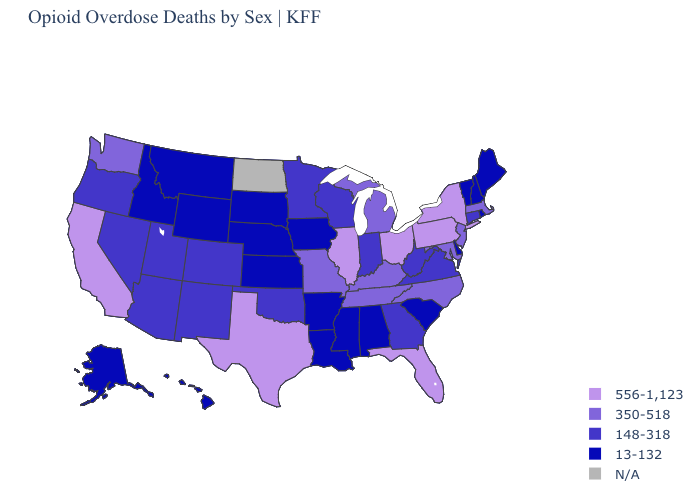Among the states that border Pennsylvania , which have the highest value?
Keep it brief. New York, Ohio. Name the states that have a value in the range 13-132?
Short answer required. Alabama, Alaska, Arkansas, Delaware, Hawaii, Idaho, Iowa, Kansas, Louisiana, Maine, Mississippi, Montana, Nebraska, New Hampshire, Rhode Island, South Carolina, South Dakota, Vermont, Wyoming. Does the map have missing data?
Give a very brief answer. Yes. What is the value of Michigan?
Be succinct. 350-518. Does New Hampshire have the highest value in the Northeast?
Give a very brief answer. No. What is the lowest value in states that border Mississippi?
Short answer required. 13-132. Does the map have missing data?
Keep it brief. Yes. Does West Virginia have the highest value in the USA?
Concise answer only. No. Name the states that have a value in the range 556-1,123?
Keep it brief. California, Florida, Illinois, New York, Ohio, Pennsylvania, Texas. Does Tennessee have the lowest value in the USA?
Give a very brief answer. No. Which states hav the highest value in the West?
Be succinct. California. What is the highest value in states that border Arkansas?
Keep it brief. 556-1,123. What is the value of Vermont?
Short answer required. 13-132. Which states have the lowest value in the USA?
Answer briefly. Alabama, Alaska, Arkansas, Delaware, Hawaii, Idaho, Iowa, Kansas, Louisiana, Maine, Mississippi, Montana, Nebraska, New Hampshire, Rhode Island, South Carolina, South Dakota, Vermont, Wyoming. 